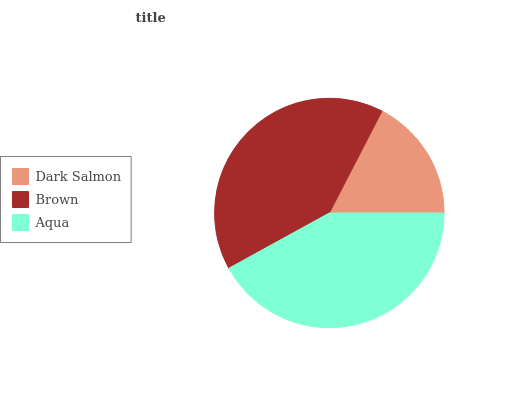Is Dark Salmon the minimum?
Answer yes or no. Yes. Is Aqua the maximum?
Answer yes or no. Yes. Is Brown the minimum?
Answer yes or no. No. Is Brown the maximum?
Answer yes or no. No. Is Brown greater than Dark Salmon?
Answer yes or no. Yes. Is Dark Salmon less than Brown?
Answer yes or no. Yes. Is Dark Salmon greater than Brown?
Answer yes or no. No. Is Brown less than Dark Salmon?
Answer yes or no. No. Is Brown the high median?
Answer yes or no. Yes. Is Brown the low median?
Answer yes or no. Yes. Is Aqua the high median?
Answer yes or no. No. Is Dark Salmon the low median?
Answer yes or no. No. 